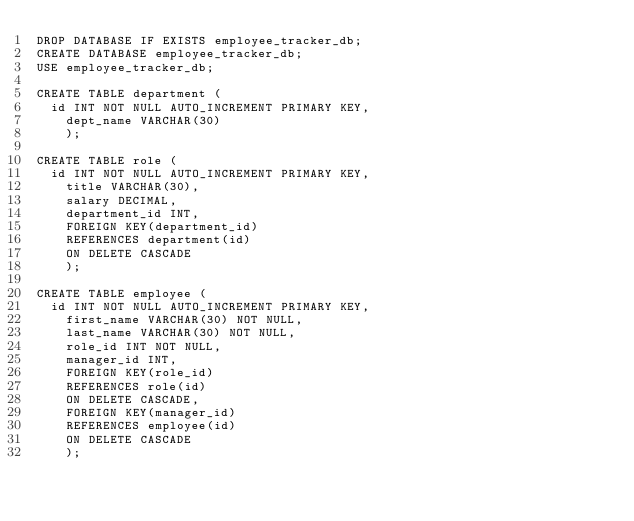Convert code to text. <code><loc_0><loc_0><loc_500><loc_500><_SQL_>DROP DATABASE IF EXISTS employee_tracker_db;
CREATE DATABASE employee_tracker_db;
USE employee_tracker_db;

CREATE TABLE department (
	id INT NOT NULL AUTO_INCREMENT PRIMARY KEY,  
    dept_name VARCHAR(30) 
    );
    
CREATE TABLE role (
	id INT NOT NULL AUTO_INCREMENT PRIMARY KEY,     
    title VARCHAR(30),     
    salary DECIMAL,     
    department_id INT,     
    FOREIGN KEY(department_id) 
    REFERENCES department(id) 
    ON DELETE CASCADE 
    );
    
CREATE TABLE employee ( 
	id INT NOT NULL AUTO_INCREMENT PRIMARY KEY, 
    first_name VARCHAR(30) NOT NULL, 
    last_name VARCHAR(30) NOT NULL, 
    role_id INT NOT NULL, 
    manager_id INT, 
    FOREIGN KEY(role_id) 
    REFERENCES role(id) 
    ON DELETE CASCADE, 
    FOREIGN KEY(manager_id) 
    REFERENCES employee(id) 
    ON DELETE CASCADE 
    );
	
    </code> 